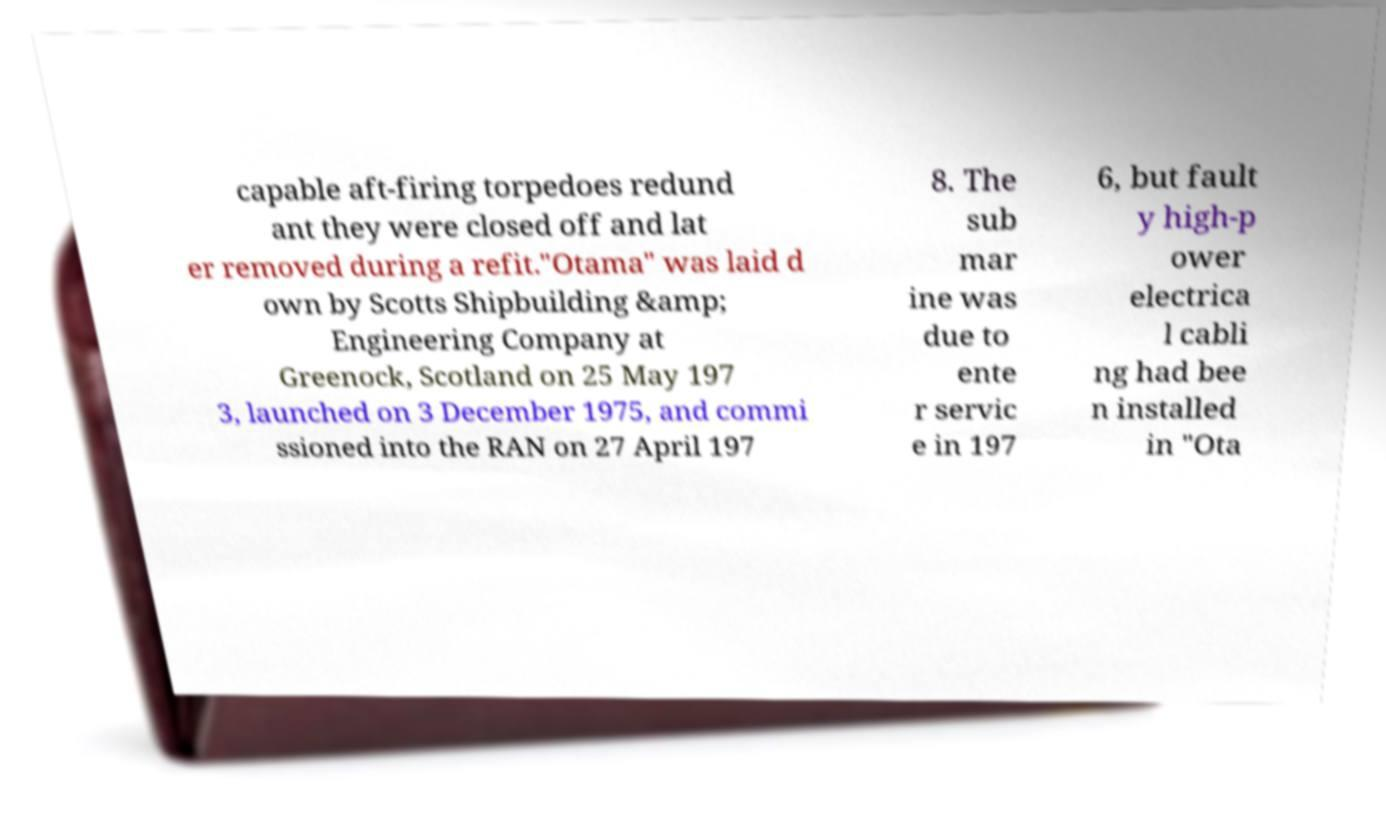For documentation purposes, I need the text within this image transcribed. Could you provide that? capable aft-firing torpedoes redund ant they were closed off and lat er removed during a refit."Otama" was laid d own by Scotts Shipbuilding &amp; Engineering Company at Greenock, Scotland on 25 May 197 3, launched on 3 December 1975, and commi ssioned into the RAN on 27 April 197 8. The sub mar ine was due to ente r servic e in 197 6, but fault y high-p ower electrica l cabli ng had bee n installed in "Ota 